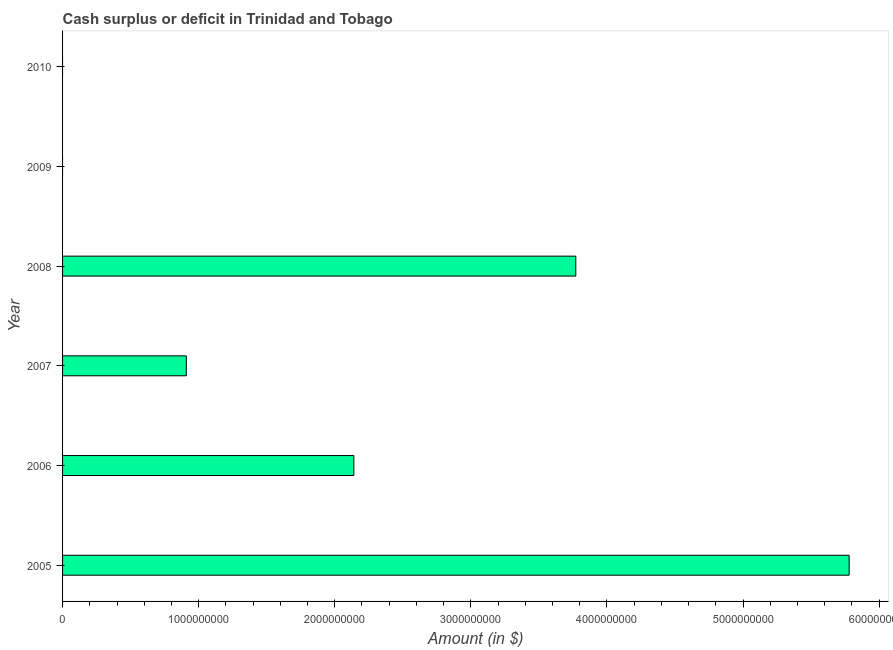Does the graph contain any zero values?
Your response must be concise. Yes. What is the title of the graph?
Your answer should be compact. Cash surplus or deficit in Trinidad and Tobago. What is the label or title of the X-axis?
Give a very brief answer. Amount (in $). What is the label or title of the Y-axis?
Offer a very short reply. Year. What is the cash surplus or deficit in 2005?
Offer a very short reply. 5.78e+09. Across all years, what is the maximum cash surplus or deficit?
Make the answer very short. 5.78e+09. What is the sum of the cash surplus or deficit?
Give a very brief answer. 1.26e+1. What is the difference between the cash surplus or deficit in 2005 and 2007?
Ensure brevity in your answer.  4.87e+09. What is the average cash surplus or deficit per year?
Offer a very short reply. 2.10e+09. What is the median cash surplus or deficit?
Keep it short and to the point. 1.52e+09. What is the ratio of the cash surplus or deficit in 2007 to that in 2008?
Your response must be concise. 0.24. Is the difference between the cash surplus or deficit in 2005 and 2008 greater than the difference between any two years?
Give a very brief answer. No. What is the difference between the highest and the second highest cash surplus or deficit?
Your answer should be compact. 2.01e+09. Is the sum of the cash surplus or deficit in 2006 and 2008 greater than the maximum cash surplus or deficit across all years?
Make the answer very short. Yes. What is the difference between the highest and the lowest cash surplus or deficit?
Your response must be concise. 5.78e+09. Are all the bars in the graph horizontal?
Keep it short and to the point. Yes. Are the values on the major ticks of X-axis written in scientific E-notation?
Provide a short and direct response. No. What is the Amount (in $) of 2005?
Your answer should be very brief. 5.78e+09. What is the Amount (in $) of 2006?
Your answer should be compact. 2.14e+09. What is the Amount (in $) of 2007?
Offer a very short reply. 9.09e+08. What is the Amount (in $) of 2008?
Your answer should be compact. 3.77e+09. What is the Amount (in $) in 2010?
Provide a short and direct response. 0. What is the difference between the Amount (in $) in 2005 and 2006?
Offer a terse response. 3.64e+09. What is the difference between the Amount (in $) in 2005 and 2007?
Provide a short and direct response. 4.87e+09. What is the difference between the Amount (in $) in 2005 and 2008?
Give a very brief answer. 2.01e+09. What is the difference between the Amount (in $) in 2006 and 2007?
Ensure brevity in your answer.  1.23e+09. What is the difference between the Amount (in $) in 2006 and 2008?
Your answer should be very brief. -1.63e+09. What is the difference between the Amount (in $) in 2007 and 2008?
Offer a terse response. -2.86e+09. What is the ratio of the Amount (in $) in 2005 to that in 2006?
Provide a succinct answer. 2.7. What is the ratio of the Amount (in $) in 2005 to that in 2007?
Your response must be concise. 6.36. What is the ratio of the Amount (in $) in 2005 to that in 2008?
Keep it short and to the point. 1.53. What is the ratio of the Amount (in $) in 2006 to that in 2007?
Give a very brief answer. 2.35. What is the ratio of the Amount (in $) in 2006 to that in 2008?
Offer a very short reply. 0.57. What is the ratio of the Amount (in $) in 2007 to that in 2008?
Offer a very short reply. 0.24. 